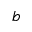<formula> <loc_0><loc_0><loc_500><loc_500>b</formula> 